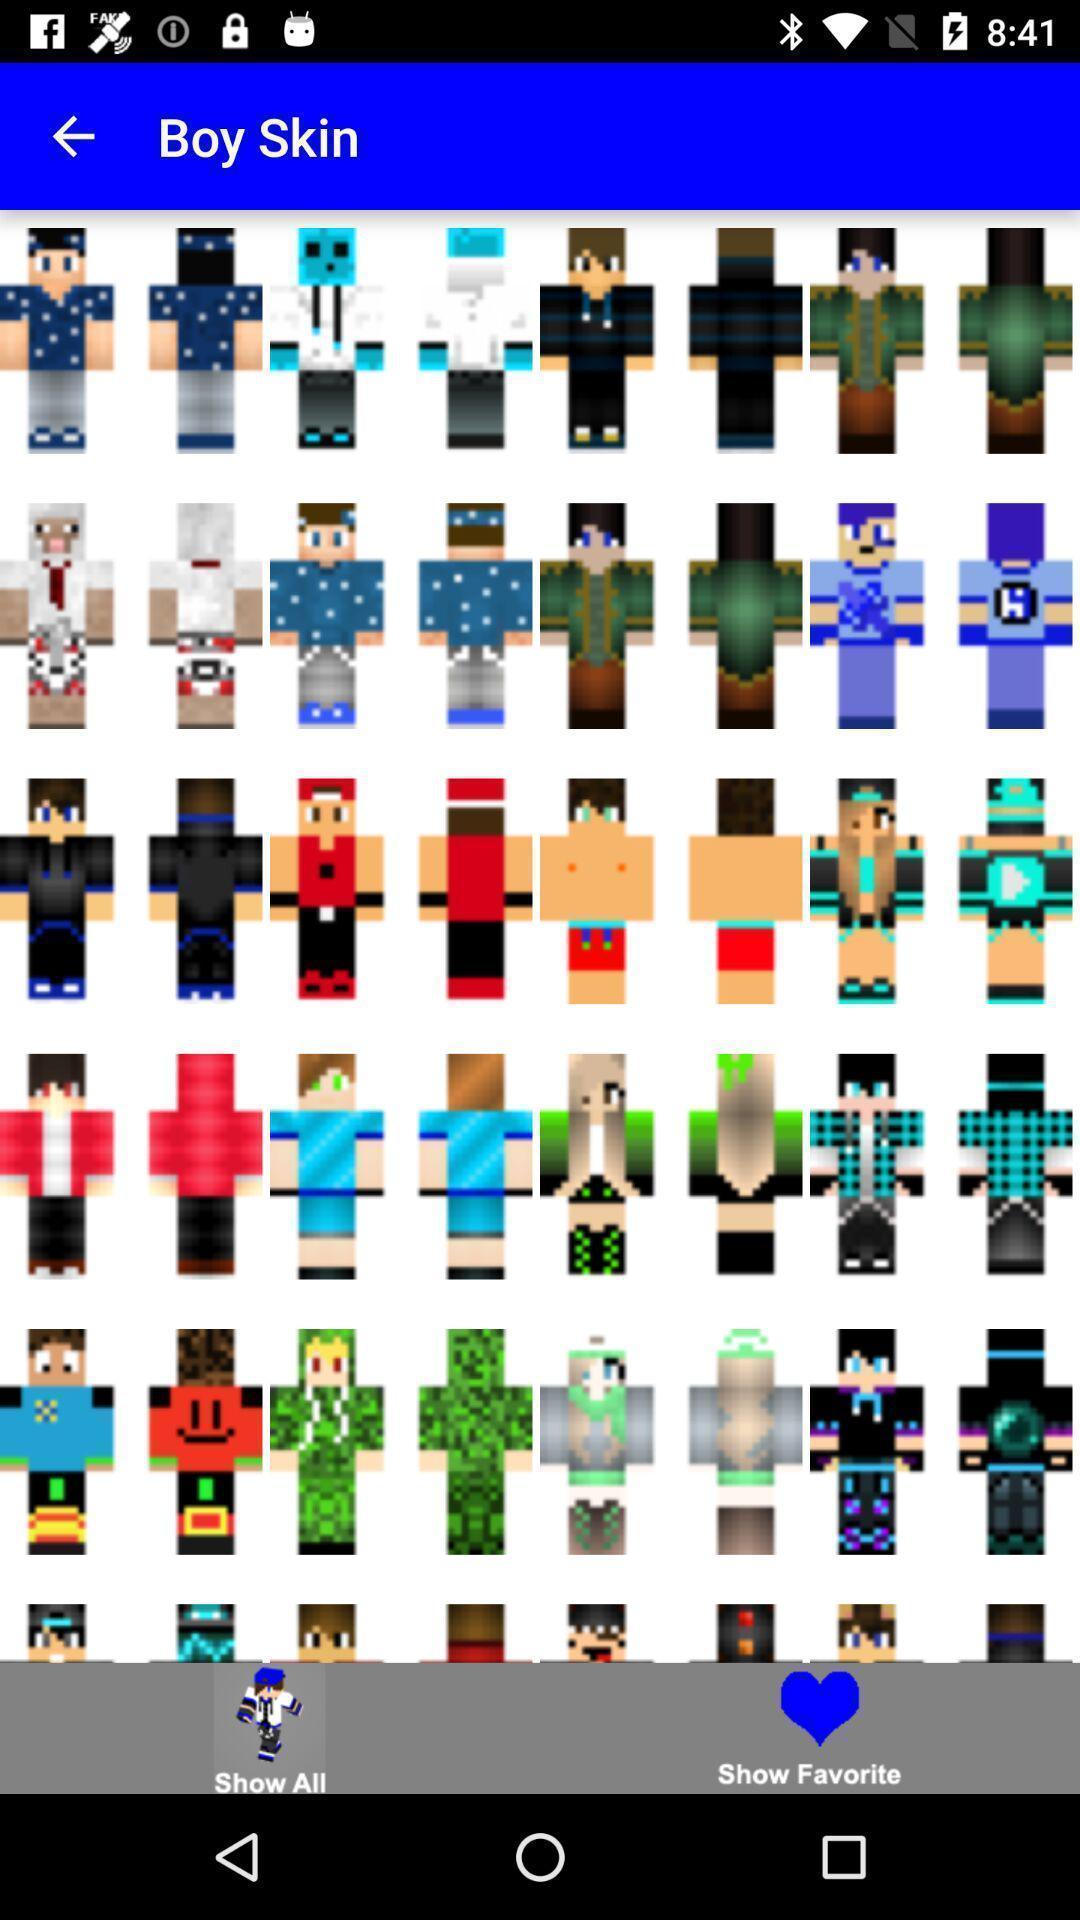Provide a description of this screenshot. Screen displaying multiple animated images. 